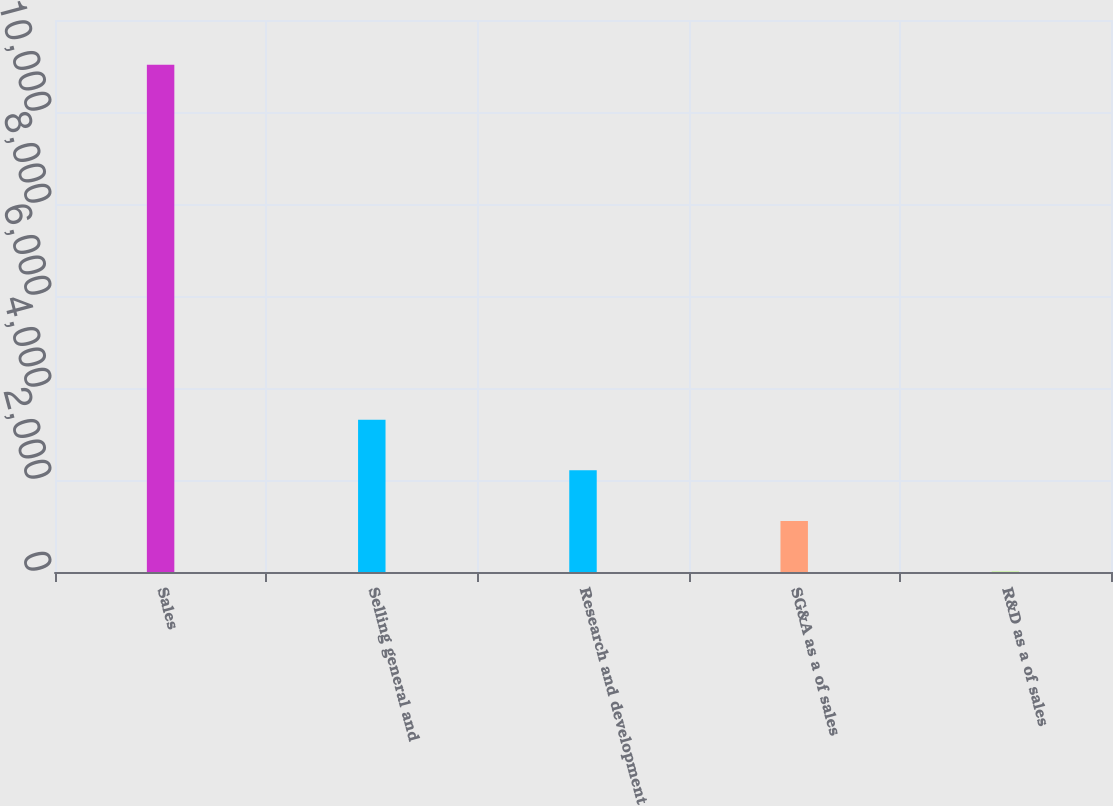Convert chart to OTSL. <chart><loc_0><loc_0><loc_500><loc_500><bar_chart><fcel>Sales<fcel>Selling general and<fcel>Research and development<fcel>SG&A as a of sales<fcel>R&D as a of sales<nl><fcel>11025.9<fcel>3311.62<fcel>2209.58<fcel>1107.54<fcel>5.5<nl></chart> 